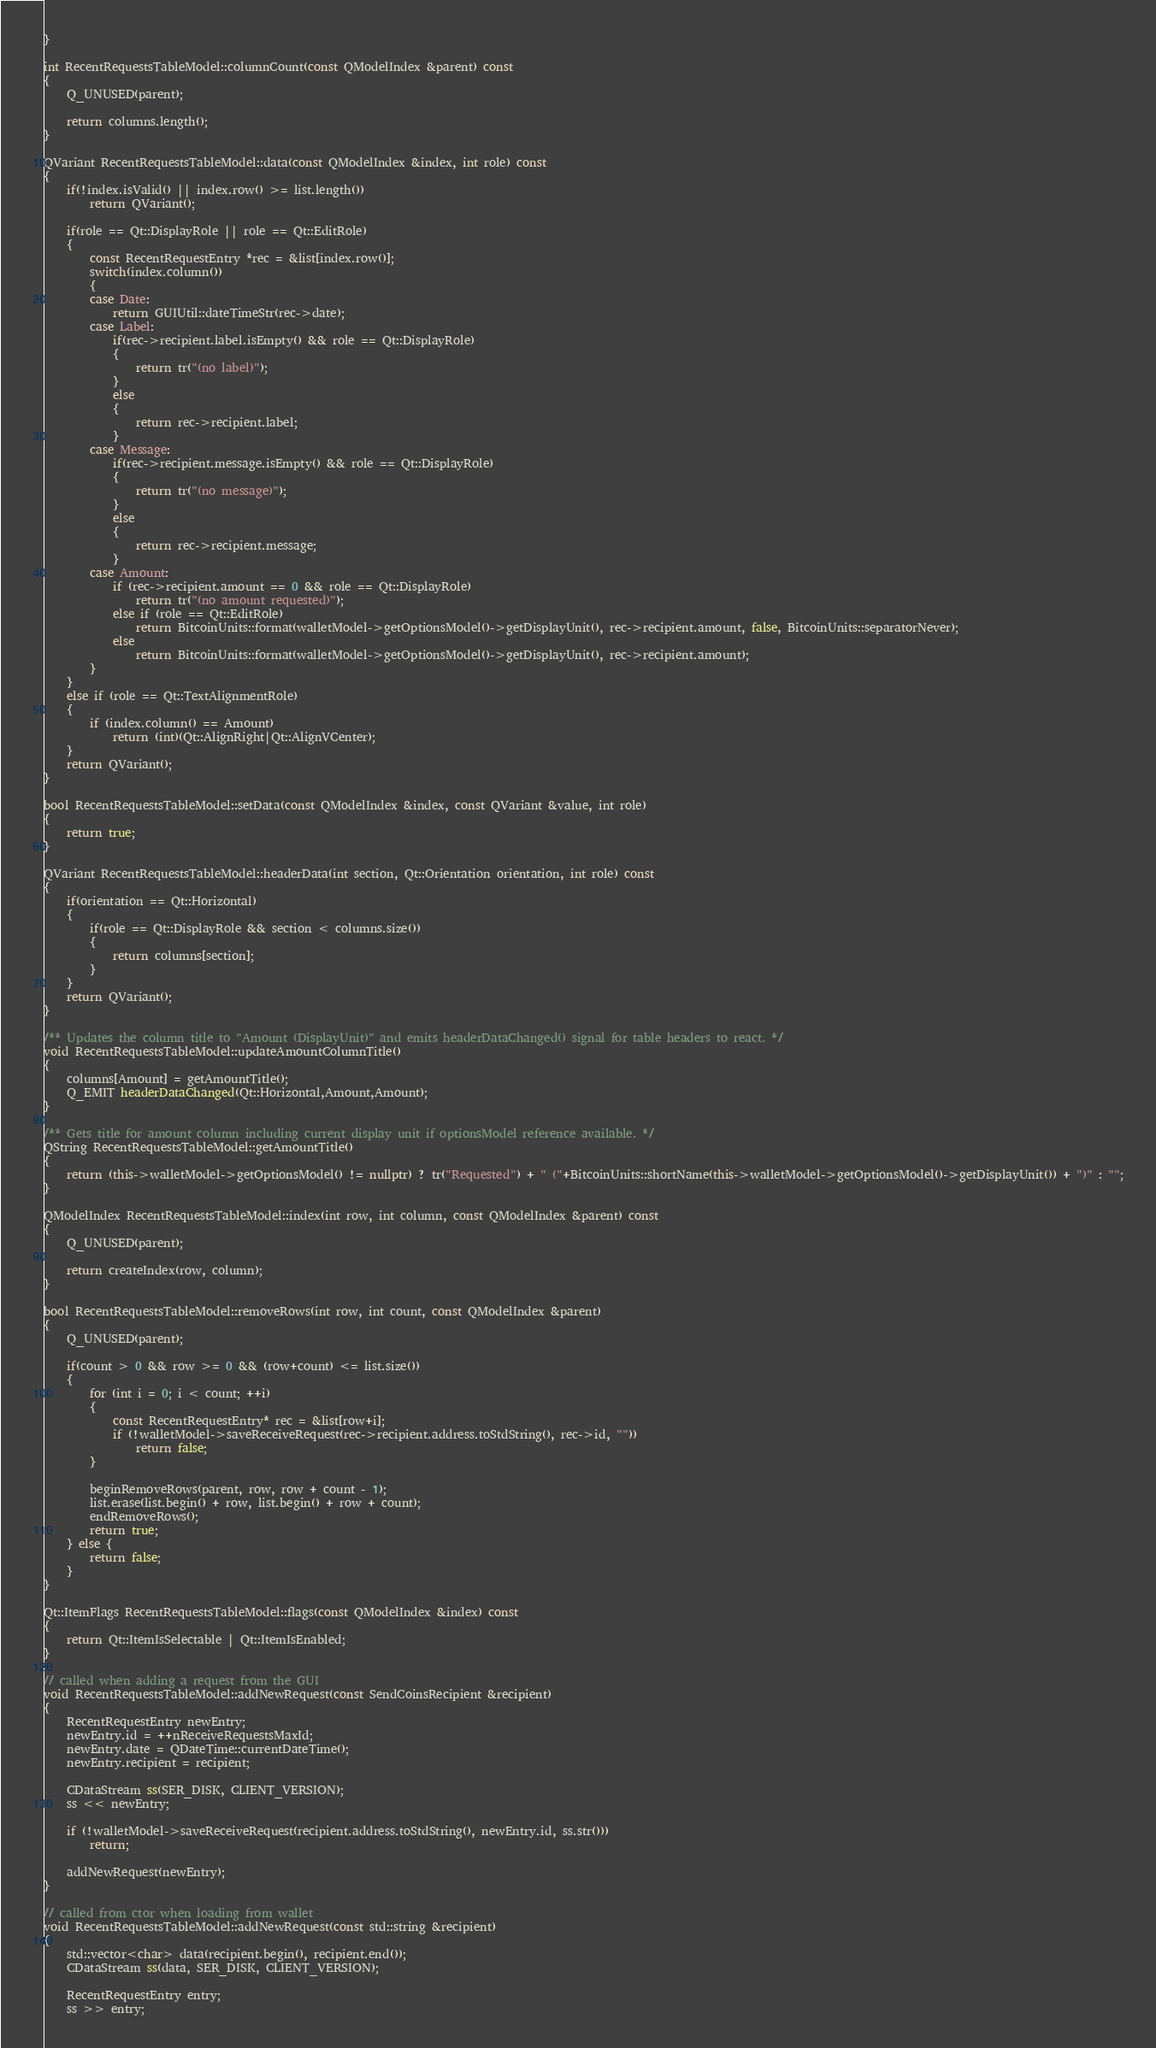<code> <loc_0><loc_0><loc_500><loc_500><_C++_>}

int RecentRequestsTableModel::columnCount(const QModelIndex &parent) const
{
    Q_UNUSED(parent);

    return columns.length();
}

QVariant RecentRequestsTableModel::data(const QModelIndex &index, int role) const
{
    if(!index.isValid() || index.row() >= list.length())
        return QVariant();

    if(role == Qt::DisplayRole || role == Qt::EditRole)
    {
        const RecentRequestEntry *rec = &list[index.row()];
        switch(index.column())
        {
        case Date:
            return GUIUtil::dateTimeStr(rec->date);
        case Label:
            if(rec->recipient.label.isEmpty() && role == Qt::DisplayRole)
            {
                return tr("(no label)");
            }
            else
            {
                return rec->recipient.label;
            }
        case Message:
            if(rec->recipient.message.isEmpty() && role == Qt::DisplayRole)
            {
                return tr("(no message)");
            }
            else
            {
                return rec->recipient.message;
            }
        case Amount:
            if (rec->recipient.amount == 0 && role == Qt::DisplayRole)
                return tr("(no amount requested)");
            else if (role == Qt::EditRole)
                return BitcoinUnits::format(walletModel->getOptionsModel()->getDisplayUnit(), rec->recipient.amount, false, BitcoinUnits::separatorNever);
            else
                return BitcoinUnits::format(walletModel->getOptionsModel()->getDisplayUnit(), rec->recipient.amount);
        }
    }
    else if (role == Qt::TextAlignmentRole)
    {
        if (index.column() == Amount)
            return (int)(Qt::AlignRight|Qt::AlignVCenter);
    }
    return QVariant();
}

bool RecentRequestsTableModel::setData(const QModelIndex &index, const QVariant &value, int role)
{
    return true;
}

QVariant RecentRequestsTableModel::headerData(int section, Qt::Orientation orientation, int role) const
{
    if(orientation == Qt::Horizontal)
    {
        if(role == Qt::DisplayRole && section < columns.size())
        {
            return columns[section];
        }
    }
    return QVariant();
}

/** Updates the column title to "Amount (DisplayUnit)" and emits headerDataChanged() signal for table headers to react. */
void RecentRequestsTableModel::updateAmountColumnTitle()
{
    columns[Amount] = getAmountTitle();
    Q_EMIT headerDataChanged(Qt::Horizontal,Amount,Amount);
}

/** Gets title for amount column including current display unit if optionsModel reference available. */
QString RecentRequestsTableModel::getAmountTitle()
{
    return (this->walletModel->getOptionsModel() != nullptr) ? tr("Requested") + " ("+BitcoinUnits::shortName(this->walletModel->getOptionsModel()->getDisplayUnit()) + ")" : "";
}

QModelIndex RecentRequestsTableModel::index(int row, int column, const QModelIndex &parent) const
{
    Q_UNUSED(parent);

    return createIndex(row, column);
}

bool RecentRequestsTableModel::removeRows(int row, int count, const QModelIndex &parent)
{
    Q_UNUSED(parent);

    if(count > 0 && row >= 0 && (row+count) <= list.size())
    {
        for (int i = 0; i < count; ++i)
        {
            const RecentRequestEntry* rec = &list[row+i];
            if (!walletModel->saveReceiveRequest(rec->recipient.address.toStdString(), rec->id, ""))
                return false;
        }

        beginRemoveRows(parent, row, row + count - 1);
        list.erase(list.begin() + row, list.begin() + row + count);
        endRemoveRows();
        return true;
    } else {
        return false;
    }
}

Qt::ItemFlags RecentRequestsTableModel::flags(const QModelIndex &index) const
{
    return Qt::ItemIsSelectable | Qt::ItemIsEnabled;
}

// called when adding a request from the GUI
void RecentRequestsTableModel::addNewRequest(const SendCoinsRecipient &recipient)
{
    RecentRequestEntry newEntry;
    newEntry.id = ++nReceiveRequestsMaxId;
    newEntry.date = QDateTime::currentDateTime();
    newEntry.recipient = recipient;

    CDataStream ss(SER_DISK, CLIENT_VERSION);
    ss << newEntry;

    if (!walletModel->saveReceiveRequest(recipient.address.toStdString(), newEntry.id, ss.str()))
        return;

    addNewRequest(newEntry);
}

// called from ctor when loading from wallet
void RecentRequestsTableModel::addNewRequest(const std::string &recipient)
{
    std::vector<char> data(recipient.begin(), recipient.end());
    CDataStream ss(data, SER_DISK, CLIENT_VERSION);

    RecentRequestEntry entry;
    ss >> entry;
</code> 